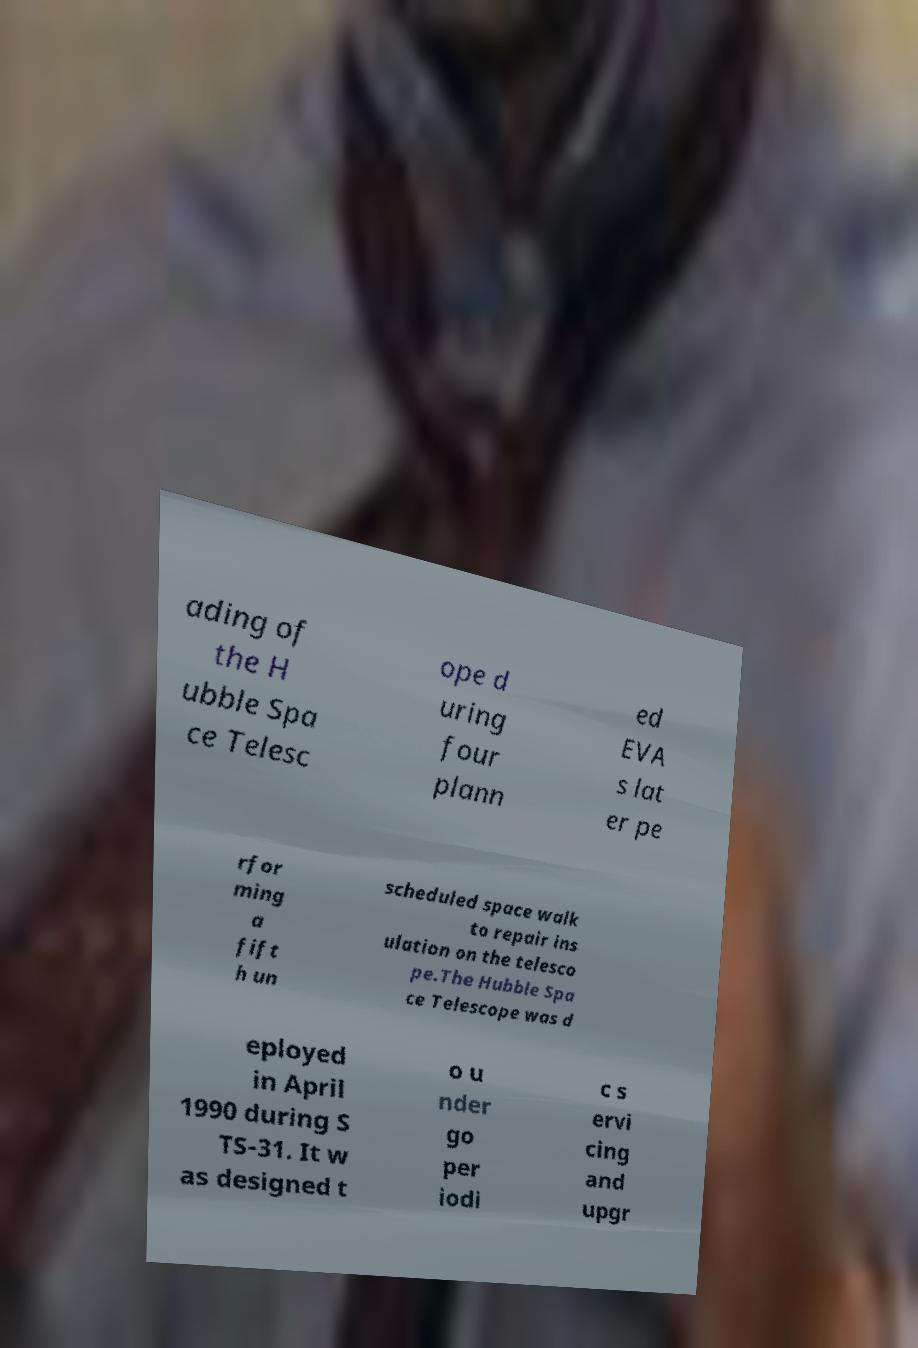Can you read and provide the text displayed in the image?This photo seems to have some interesting text. Can you extract and type it out for me? ading of the H ubble Spa ce Telesc ope d uring four plann ed EVA s lat er pe rfor ming a fift h un scheduled space walk to repair ins ulation on the telesco pe.The Hubble Spa ce Telescope was d eployed in April 1990 during S TS-31. It w as designed t o u nder go per iodi c s ervi cing and upgr 